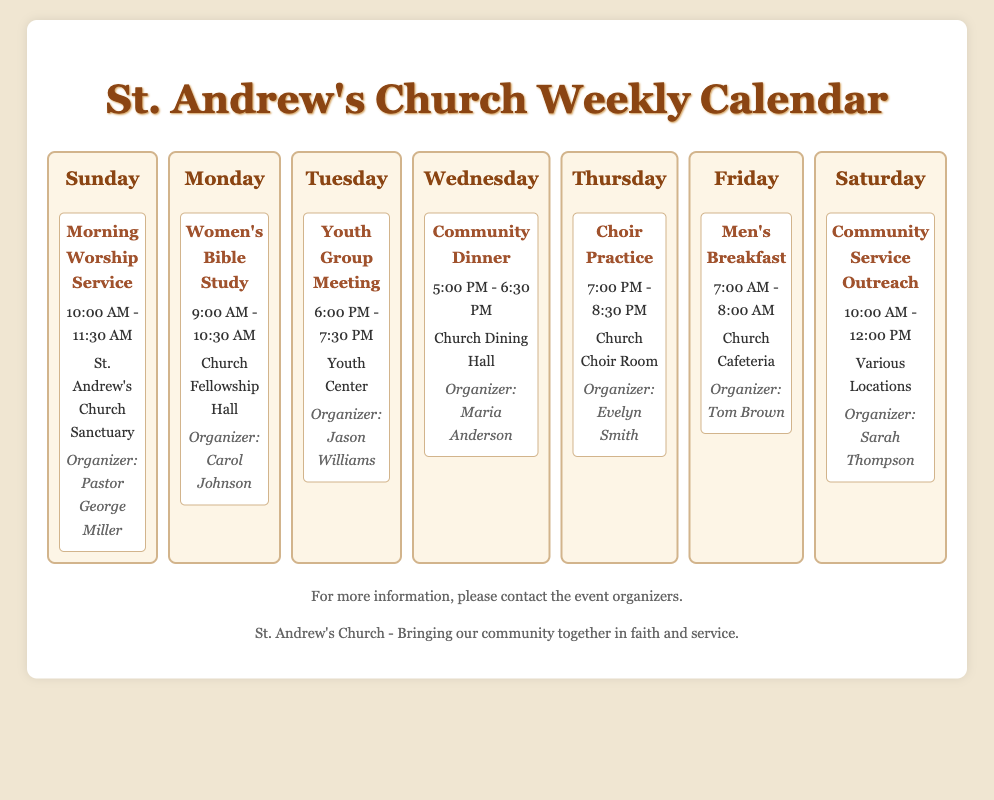What time does the Morning Worship Service start? The start time for the Morning Worship Service is listed as 10:00 AM.
Answer: 10:00 AM Who is the organizer of the Women's Bible Study? The organizer for the Women's Bible Study is mentioned as Carol Johnson.
Answer: Carol Johnson What event occurs on Wednesday? The event scheduled for Wednesday is the Community Dinner.
Answer: Community Dinner Which activity is held on Saturday? The activity on Saturday is the Community Service Outreach.
Answer: Community Service Outreach How long does the Men's Breakfast last? The Men's Breakfast is stated to last from 7:00 AM to 8:00 AM, so it lasts for one hour.
Answer: 1 hour What is the location for the Youth Group Meeting? The document states that the Youth Group Meeting takes place at the Youth Center.
Answer: Youth Center Which day features Choir Practice? Choir Practice is scheduled for Thursday.
Answer: Thursday What time does the Community Dinner begin? The Community Dinner is set to begin at 5:00 PM.
Answer: 5:00 PM Who organizes the Community Service Outreach? The organizer for the Community Service Outreach is specified as Sarah Thompson.
Answer: Sarah Thompson 